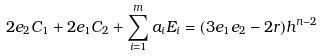Convert formula to latex. <formula><loc_0><loc_0><loc_500><loc_500>2 e _ { 2 } C _ { 1 } + 2 e _ { 1 } C _ { 2 } + \sum _ { i = 1 } ^ { m } a _ { i } E _ { i } = ( 3 e _ { 1 } e _ { 2 } - 2 r ) h ^ { n - 2 }</formula> 